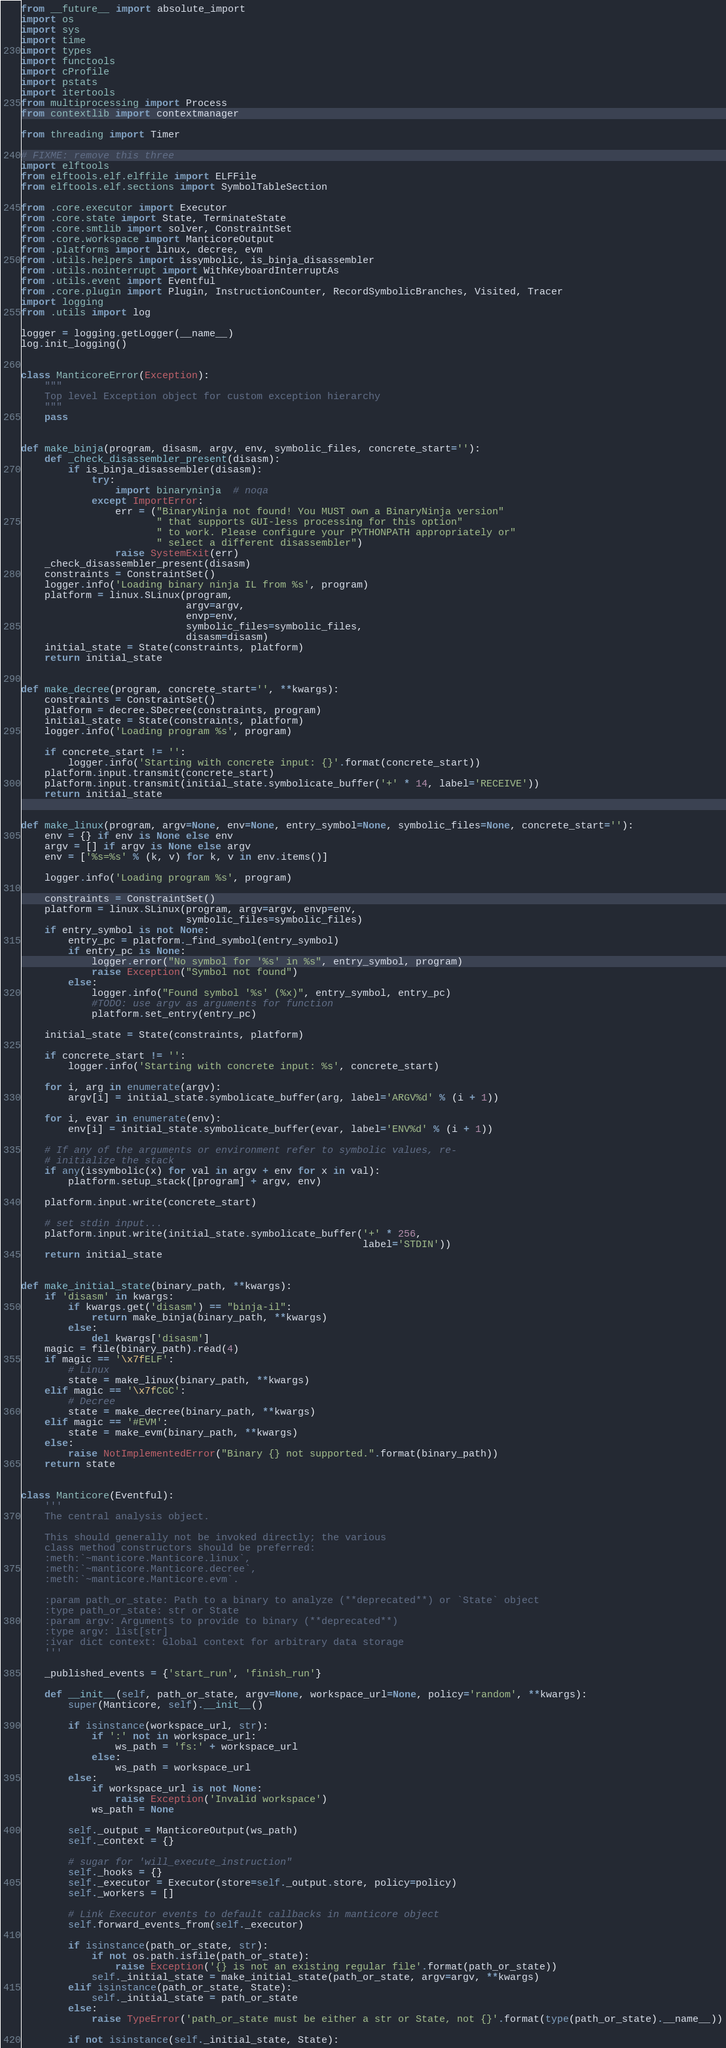Convert code to text. <code><loc_0><loc_0><loc_500><loc_500><_Python_>from __future__ import absolute_import
import os
import sys
import time
import types
import functools
import cProfile
import pstats
import itertools
from multiprocessing import Process
from contextlib import contextmanager

from threading import Timer

# FIXME: remove this three
import elftools
from elftools.elf.elffile import ELFFile
from elftools.elf.sections import SymbolTableSection

from .core.executor import Executor
from .core.state import State, TerminateState
from .core.smtlib import solver, ConstraintSet
from .core.workspace import ManticoreOutput
from .platforms import linux, decree, evm
from .utils.helpers import issymbolic, is_binja_disassembler
from .utils.nointerrupt import WithKeyboardInterruptAs
from .utils.event import Eventful
from .core.plugin import Plugin, InstructionCounter, RecordSymbolicBranches, Visited, Tracer
import logging
from .utils import log

logger = logging.getLogger(__name__)
log.init_logging()


class ManticoreError(Exception):
    """
    Top level Exception object for custom exception hierarchy
    """
    pass


def make_binja(program, disasm, argv, env, symbolic_files, concrete_start=''):
    def _check_disassembler_present(disasm):
        if is_binja_disassembler(disasm):
            try:
                import binaryninja  # noqa
            except ImportError:
                err = ("BinaryNinja not found! You MUST own a BinaryNinja version"
                       " that supports GUI-less processing for this option"
                       " to work. Please configure your PYTHONPATH appropriately or"
                       " select a different disassembler")
                raise SystemExit(err)
    _check_disassembler_present(disasm)
    constraints = ConstraintSet()
    logger.info('Loading binary ninja IL from %s', program)
    platform = linux.SLinux(program,
                            argv=argv,
                            envp=env,
                            symbolic_files=symbolic_files,
                            disasm=disasm)
    initial_state = State(constraints, platform)
    return initial_state


def make_decree(program, concrete_start='', **kwargs):
    constraints = ConstraintSet()
    platform = decree.SDecree(constraints, program)
    initial_state = State(constraints, platform)
    logger.info('Loading program %s', program)

    if concrete_start != '':
        logger.info('Starting with concrete input: {}'.format(concrete_start))
    platform.input.transmit(concrete_start)
    platform.input.transmit(initial_state.symbolicate_buffer('+' * 14, label='RECEIVE'))
    return initial_state


def make_linux(program, argv=None, env=None, entry_symbol=None, symbolic_files=None, concrete_start=''):
    env = {} if env is None else env
    argv = [] if argv is None else argv
    env = ['%s=%s' % (k, v) for k, v in env.items()]

    logger.info('Loading program %s', program)

    constraints = ConstraintSet()
    platform = linux.SLinux(program, argv=argv, envp=env,
                            symbolic_files=symbolic_files)
    if entry_symbol is not None:
        entry_pc = platform._find_symbol(entry_symbol)
        if entry_pc is None:
            logger.error("No symbol for '%s' in %s", entry_symbol, program)
            raise Exception("Symbol not found")
        else:
            logger.info("Found symbol '%s' (%x)", entry_symbol, entry_pc)
            #TODO: use argv as arguments for function
            platform.set_entry(entry_pc)

    initial_state = State(constraints, platform)

    if concrete_start != '':
        logger.info('Starting with concrete input: %s', concrete_start)

    for i, arg in enumerate(argv):
        argv[i] = initial_state.symbolicate_buffer(arg, label='ARGV%d' % (i + 1))

    for i, evar in enumerate(env):
        env[i] = initial_state.symbolicate_buffer(evar, label='ENV%d' % (i + 1))

    # If any of the arguments or environment refer to symbolic values, re-
    # initialize the stack
    if any(issymbolic(x) for val in argv + env for x in val):
        platform.setup_stack([program] + argv, env)

    platform.input.write(concrete_start)

    # set stdin input...
    platform.input.write(initial_state.symbolicate_buffer('+' * 256,
                                                          label='STDIN'))
    return initial_state


def make_initial_state(binary_path, **kwargs):
    if 'disasm' in kwargs:
        if kwargs.get('disasm') == "binja-il":
            return make_binja(binary_path, **kwargs)
        else:
            del kwargs['disasm']
    magic = file(binary_path).read(4)
    if magic == '\x7fELF':
        # Linux
        state = make_linux(binary_path, **kwargs)
    elif magic == '\x7fCGC':
        # Decree
        state = make_decree(binary_path, **kwargs)
    elif magic == '#EVM':
        state = make_evm(binary_path, **kwargs)
    else:
        raise NotImplementedError("Binary {} not supported.".format(binary_path))
    return state


class Manticore(Eventful):
    '''
    The central analysis object.

    This should generally not be invoked directly; the various
    class method constructors should be preferred:
    :meth:`~manticore.Manticore.linux`,
    :meth:`~manticore.Manticore.decree`,
    :meth:`~manticore.Manticore.evm`.

    :param path_or_state: Path to a binary to analyze (**deprecated**) or `State` object
    :type path_or_state: str or State
    :param argv: Arguments to provide to binary (**deprecated**)
    :type argv: list[str]
    :ivar dict context: Global context for arbitrary data storage
    '''

    _published_events = {'start_run', 'finish_run'}

    def __init__(self, path_or_state, argv=None, workspace_url=None, policy='random', **kwargs):
        super(Manticore, self).__init__()

        if isinstance(workspace_url, str):
            if ':' not in workspace_url:
                ws_path = 'fs:' + workspace_url
            else:
                ws_path = workspace_url
        else:
            if workspace_url is not None:
                raise Exception('Invalid workspace')
            ws_path = None

        self._output = ManticoreOutput(ws_path)
        self._context = {}

        # sugar for 'will_execute_instruction"
        self._hooks = {}
        self._executor = Executor(store=self._output.store, policy=policy)
        self._workers = []

        # Link Executor events to default callbacks in manticore object
        self.forward_events_from(self._executor)

        if isinstance(path_or_state, str):
            if not os.path.isfile(path_or_state):
                raise Exception('{} is not an existing regular file'.format(path_or_state))
            self._initial_state = make_initial_state(path_or_state, argv=argv, **kwargs)
        elif isinstance(path_or_state, State):
            self._initial_state = path_or_state
        else:
            raise TypeError('path_or_state must be either a str or State, not {}'.format(type(path_or_state).__name__))

        if not isinstance(self._initial_state, State):</code> 